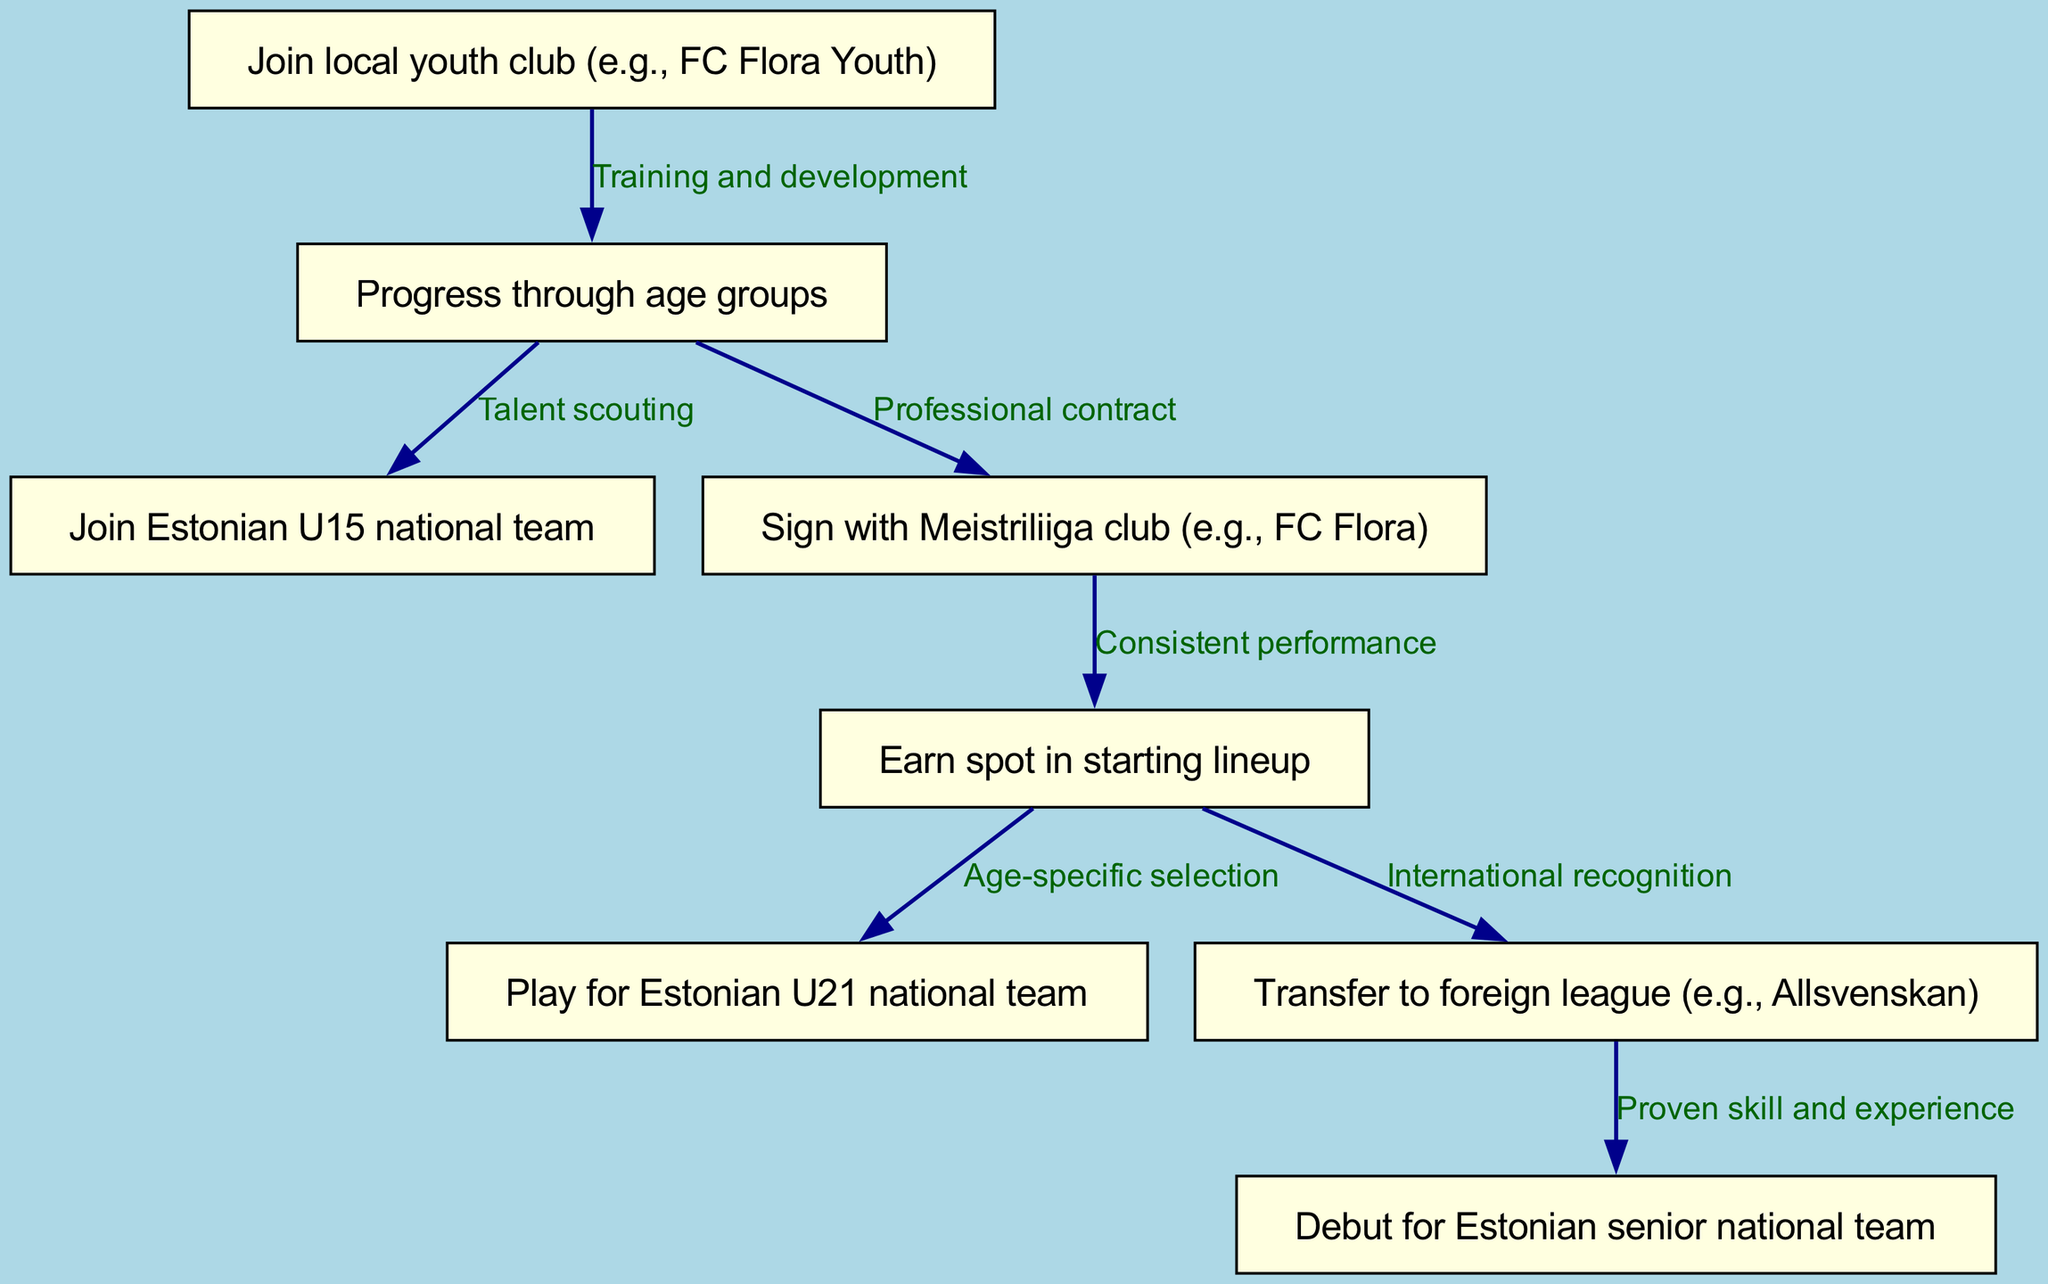What is the first step a player takes in the journey? The first node in the diagram shows that a player joins a local youth club, which is the initial step in the journey.
Answer: Join local youth club (e.g., FC Flora Youth) How many nodes are there in the diagram? Counting the nodes listed in the data, there are eight nodes that represent different steps in the player's journey.
Answer: 8 What is the relationship between "Sign with Meistriliiga club (e.g., FC Flora)" and "Play for Estonian U21 national team"? The flow indicates that after a player earns a spot in the starting lineup of their Meistriliiga club, they may go on to be selected for the Estonian U21 national team, showing a direct progression.
Answer: Age-specific selection What step follows after "Transfer to foreign league (e.g., Allsvenskan)"? The edge emanating from the node for transferring to a foreign league points directly to the debut for the Estonian senior national team, indicating this is the next stage in the journey.
Answer: Debut for Estonian senior national team What is the main reason why a player moves from "Earn spot in starting lineup" to "Play for Estonian U21 national team"? The reason for this transition is specified as 'Age-specific selection', meaning that the player's performance at the club level leads to selection for the U21 national team based on their age and talent.
Answer: Age-specific selection What must a player achieve in the Meistriliiga to progress to the U21 national team? The player must achieve consistent performance at their club, which is necessary for being considered for the national team selection.
Answer: Consistent performance How does a player usually progress from youth academy to Estonian U15 national team? The progression occurs through talent scouting, which identifies promising players from the youth academy to join the U15 national team.
Answer: Talent scouting What is the final achievement in the journey of this football player? The last step shown in the diagram is debuting for the Estonian senior national team, which is the ultimate goal of the journey depicted.
Answer: Debut for Estonian senior national team 